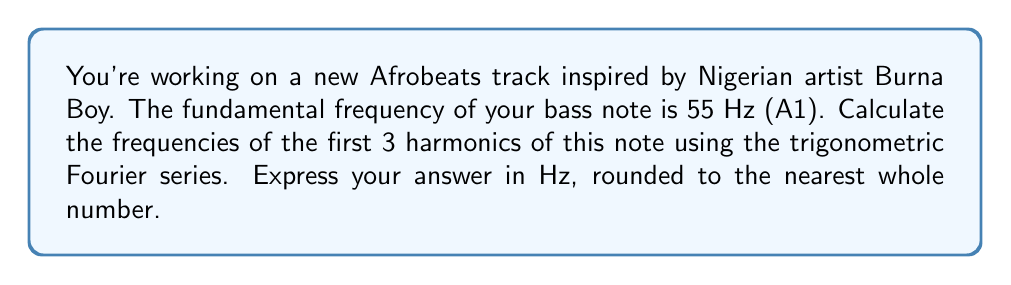Can you answer this question? To solve this problem, we need to understand the concept of harmonics and how they relate to the fundamental frequency.

1. The fundamental frequency (f) is the lowest frequency of a periodic waveform. In this case, f = 55 Hz.

2. Harmonics are integer multiples of the fundamental frequency. The nth harmonic is given by the formula:

   $f_n = n \cdot f$

   where n is the harmonic number and f is the fundamental frequency.

3. Let's calculate the first 3 harmonics:

   First harmonic (n = 1):
   $f_1 = 1 \cdot 55 = 55$ Hz
   This is actually the fundamental frequency itself.

   Second harmonic (n = 2):
   $f_2 = 2 \cdot 55 = 110$ Hz

   Third harmonic (n = 3):
   $f_3 = 3 \cdot 55 = 165$ Hz

4. The Fourier series for a periodic waveform can be expressed as:

   $$f(t) = A_0 + \sum_{n=1}^{\infty} A_n \cos(2\pi n f t) + B_n \sin(2\pi n f t)$$

   where $A_0$, $A_n$, and $B_n$ are coefficients that determine the amplitude of each harmonic.

5. In the context of this question, we're only concerned with the frequencies of the harmonics, not their amplitudes. The frequencies appear in the arguments of the cosine and sine functions as $2\pi n f$.

6. Rounding the results to the nearest whole number, we get:
   First harmonic: 55 Hz
   Second harmonic: 110 Hz
   Third harmonic: 165 Hz
Answer: The frequencies of the first 3 harmonics are 55 Hz, 110 Hz, and 165 Hz. 